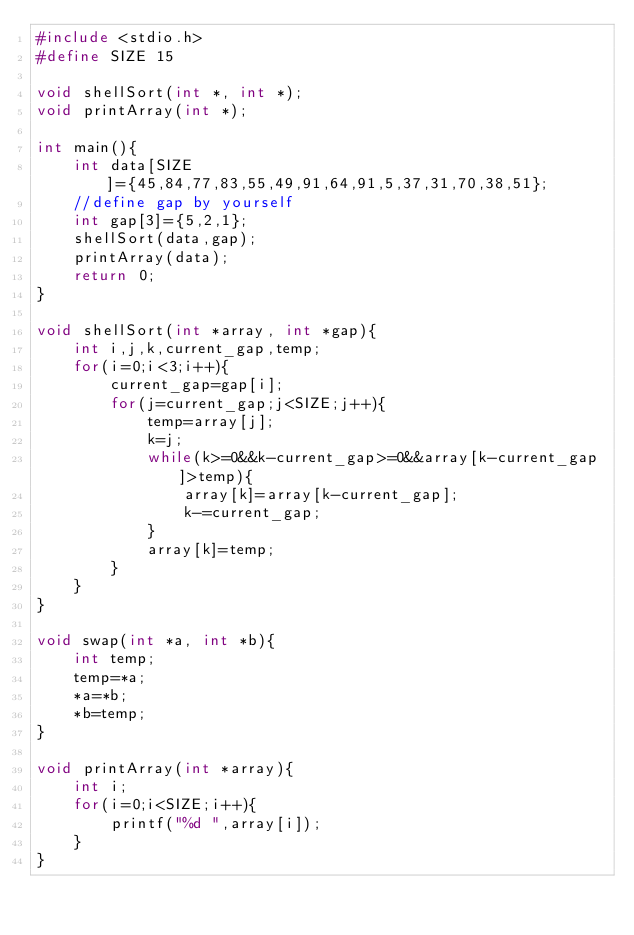Convert code to text. <code><loc_0><loc_0><loc_500><loc_500><_C_>#include <stdio.h>
#define SIZE 15

void shellSort(int *, int *);
void printArray(int *);

int main(){
	int data[SIZE]={45,84,77,83,55,49,91,64,91,5,37,31,70,38,51};
	//define gap by yourself
	int gap[3]={5,2,1};
	shellSort(data,gap);
	printArray(data);
	return 0;
}

void shellSort(int *array, int *gap){
	int i,j,k,current_gap,temp;
	for(i=0;i<3;i++){
		current_gap=gap[i];
		for(j=current_gap;j<SIZE;j++){
			temp=array[j];
			k=j;
			while(k>=0&&k-current_gap>=0&&array[k-current_gap]>temp){
				array[k]=array[k-current_gap];
				k-=current_gap;
			}
			array[k]=temp;
		}
	}
}

void swap(int *a, int *b){
	int temp;
	temp=*a;
	*a=*b;
	*b=temp;
}

void printArray(int *array){
	int i;
	for(i=0;i<SIZE;i++){
		printf("%d ",array[i]);
	}
}
</code> 